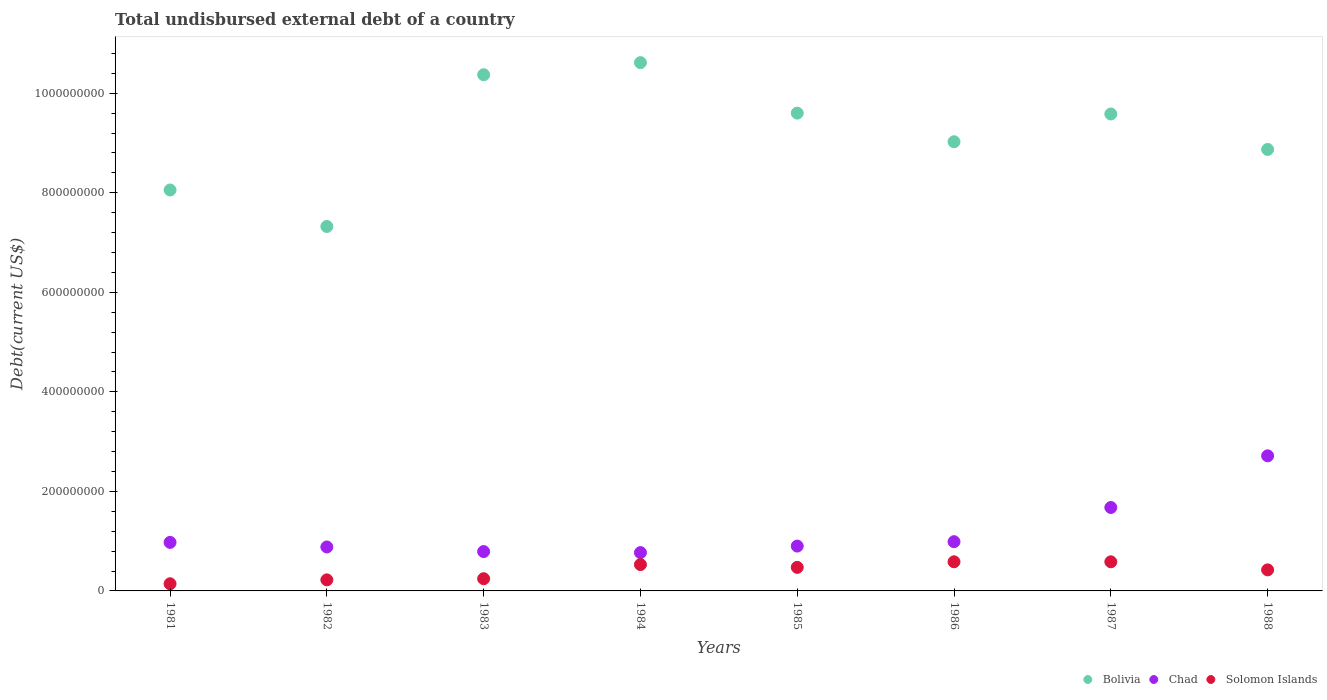What is the total undisbursed external debt in Bolivia in 1988?
Provide a succinct answer. 8.87e+08. Across all years, what is the maximum total undisbursed external debt in Chad?
Offer a terse response. 2.71e+08. Across all years, what is the minimum total undisbursed external debt in Chad?
Keep it short and to the point. 7.70e+07. In which year was the total undisbursed external debt in Bolivia maximum?
Provide a short and direct response. 1984. What is the total total undisbursed external debt in Bolivia in the graph?
Provide a succinct answer. 7.34e+09. What is the difference between the total undisbursed external debt in Chad in 1985 and that in 1987?
Keep it short and to the point. -7.75e+07. What is the difference between the total undisbursed external debt in Chad in 1988 and the total undisbursed external debt in Bolivia in 1982?
Ensure brevity in your answer.  -4.61e+08. What is the average total undisbursed external debt in Solomon Islands per year?
Provide a short and direct response. 4.01e+07. In the year 1984, what is the difference between the total undisbursed external debt in Solomon Islands and total undisbursed external debt in Bolivia?
Offer a terse response. -1.01e+09. What is the ratio of the total undisbursed external debt in Chad in 1983 to that in 1988?
Your answer should be very brief. 0.29. What is the difference between the highest and the second highest total undisbursed external debt in Solomon Islands?
Give a very brief answer. 2.10e+04. What is the difference between the highest and the lowest total undisbursed external debt in Chad?
Your answer should be very brief. 1.94e+08. In how many years, is the total undisbursed external debt in Chad greater than the average total undisbursed external debt in Chad taken over all years?
Your response must be concise. 2. Is the sum of the total undisbursed external debt in Solomon Islands in 1984 and 1988 greater than the maximum total undisbursed external debt in Chad across all years?
Offer a very short reply. No. Is it the case that in every year, the sum of the total undisbursed external debt in Solomon Islands and total undisbursed external debt in Chad  is greater than the total undisbursed external debt in Bolivia?
Make the answer very short. No. Does the total undisbursed external debt in Solomon Islands monotonically increase over the years?
Your answer should be very brief. No. Is the total undisbursed external debt in Bolivia strictly greater than the total undisbursed external debt in Chad over the years?
Keep it short and to the point. Yes. How many years are there in the graph?
Your answer should be very brief. 8. Does the graph contain any zero values?
Make the answer very short. No. Does the graph contain grids?
Make the answer very short. No. How are the legend labels stacked?
Your answer should be very brief. Horizontal. What is the title of the graph?
Your response must be concise. Total undisbursed external debt of a country. What is the label or title of the X-axis?
Your answer should be compact. Years. What is the label or title of the Y-axis?
Provide a succinct answer. Debt(current US$). What is the Debt(current US$) of Bolivia in 1981?
Your answer should be compact. 8.06e+08. What is the Debt(current US$) in Chad in 1981?
Offer a very short reply. 9.75e+07. What is the Debt(current US$) in Solomon Islands in 1981?
Provide a succinct answer. 1.44e+07. What is the Debt(current US$) in Bolivia in 1982?
Provide a succinct answer. 7.32e+08. What is the Debt(current US$) in Chad in 1982?
Your response must be concise. 8.83e+07. What is the Debt(current US$) of Solomon Islands in 1982?
Offer a terse response. 2.22e+07. What is the Debt(current US$) in Bolivia in 1983?
Give a very brief answer. 1.04e+09. What is the Debt(current US$) in Chad in 1983?
Offer a very short reply. 7.91e+07. What is the Debt(current US$) in Solomon Islands in 1983?
Offer a very short reply. 2.45e+07. What is the Debt(current US$) of Bolivia in 1984?
Make the answer very short. 1.06e+09. What is the Debt(current US$) in Chad in 1984?
Your answer should be compact. 7.70e+07. What is the Debt(current US$) in Solomon Islands in 1984?
Give a very brief answer. 5.29e+07. What is the Debt(current US$) in Bolivia in 1985?
Give a very brief answer. 9.60e+08. What is the Debt(current US$) of Chad in 1985?
Give a very brief answer. 9.01e+07. What is the Debt(current US$) of Solomon Islands in 1985?
Your answer should be very brief. 4.73e+07. What is the Debt(current US$) in Bolivia in 1986?
Ensure brevity in your answer.  9.02e+08. What is the Debt(current US$) of Chad in 1986?
Keep it short and to the point. 9.89e+07. What is the Debt(current US$) in Solomon Islands in 1986?
Provide a succinct answer. 5.85e+07. What is the Debt(current US$) of Bolivia in 1987?
Keep it short and to the point. 9.58e+08. What is the Debt(current US$) in Chad in 1987?
Provide a succinct answer. 1.68e+08. What is the Debt(current US$) of Solomon Islands in 1987?
Give a very brief answer. 5.85e+07. What is the Debt(current US$) of Bolivia in 1988?
Your response must be concise. 8.87e+08. What is the Debt(current US$) in Chad in 1988?
Your answer should be compact. 2.71e+08. What is the Debt(current US$) of Solomon Islands in 1988?
Offer a terse response. 4.23e+07. Across all years, what is the maximum Debt(current US$) of Bolivia?
Your response must be concise. 1.06e+09. Across all years, what is the maximum Debt(current US$) in Chad?
Offer a terse response. 2.71e+08. Across all years, what is the maximum Debt(current US$) of Solomon Islands?
Ensure brevity in your answer.  5.85e+07. Across all years, what is the minimum Debt(current US$) of Bolivia?
Offer a terse response. 7.32e+08. Across all years, what is the minimum Debt(current US$) of Chad?
Your answer should be compact. 7.70e+07. Across all years, what is the minimum Debt(current US$) in Solomon Islands?
Give a very brief answer. 1.44e+07. What is the total Debt(current US$) of Bolivia in the graph?
Offer a terse response. 7.34e+09. What is the total Debt(current US$) of Chad in the graph?
Give a very brief answer. 9.70e+08. What is the total Debt(current US$) of Solomon Islands in the graph?
Give a very brief answer. 3.21e+08. What is the difference between the Debt(current US$) of Bolivia in 1981 and that in 1982?
Your answer should be very brief. 7.33e+07. What is the difference between the Debt(current US$) of Chad in 1981 and that in 1982?
Provide a succinct answer. 9.19e+06. What is the difference between the Debt(current US$) of Solomon Islands in 1981 and that in 1982?
Your answer should be very brief. -7.85e+06. What is the difference between the Debt(current US$) of Bolivia in 1981 and that in 1983?
Keep it short and to the point. -2.32e+08. What is the difference between the Debt(current US$) in Chad in 1981 and that in 1983?
Your answer should be compact. 1.84e+07. What is the difference between the Debt(current US$) of Solomon Islands in 1981 and that in 1983?
Your response must be concise. -1.02e+07. What is the difference between the Debt(current US$) in Bolivia in 1981 and that in 1984?
Your answer should be very brief. -2.56e+08. What is the difference between the Debt(current US$) of Chad in 1981 and that in 1984?
Make the answer very short. 2.05e+07. What is the difference between the Debt(current US$) of Solomon Islands in 1981 and that in 1984?
Keep it short and to the point. -3.85e+07. What is the difference between the Debt(current US$) in Bolivia in 1981 and that in 1985?
Your answer should be very brief. -1.54e+08. What is the difference between the Debt(current US$) of Chad in 1981 and that in 1985?
Ensure brevity in your answer.  7.40e+06. What is the difference between the Debt(current US$) in Solomon Islands in 1981 and that in 1985?
Make the answer very short. -3.30e+07. What is the difference between the Debt(current US$) of Bolivia in 1981 and that in 1986?
Your answer should be compact. -9.69e+07. What is the difference between the Debt(current US$) of Chad in 1981 and that in 1986?
Provide a short and direct response. -1.39e+06. What is the difference between the Debt(current US$) in Solomon Islands in 1981 and that in 1986?
Your answer should be compact. -4.42e+07. What is the difference between the Debt(current US$) of Bolivia in 1981 and that in 1987?
Keep it short and to the point. -1.53e+08. What is the difference between the Debt(current US$) in Chad in 1981 and that in 1987?
Your response must be concise. -7.01e+07. What is the difference between the Debt(current US$) of Solomon Islands in 1981 and that in 1987?
Offer a terse response. -4.41e+07. What is the difference between the Debt(current US$) of Bolivia in 1981 and that in 1988?
Keep it short and to the point. -8.15e+07. What is the difference between the Debt(current US$) in Chad in 1981 and that in 1988?
Ensure brevity in your answer.  -1.74e+08. What is the difference between the Debt(current US$) of Solomon Islands in 1981 and that in 1988?
Make the answer very short. -2.79e+07. What is the difference between the Debt(current US$) of Bolivia in 1982 and that in 1983?
Your response must be concise. -3.05e+08. What is the difference between the Debt(current US$) in Chad in 1982 and that in 1983?
Provide a short and direct response. 9.26e+06. What is the difference between the Debt(current US$) in Solomon Islands in 1982 and that in 1983?
Your answer should be compact. -2.31e+06. What is the difference between the Debt(current US$) in Bolivia in 1982 and that in 1984?
Your answer should be very brief. -3.29e+08. What is the difference between the Debt(current US$) of Chad in 1982 and that in 1984?
Offer a terse response. 1.13e+07. What is the difference between the Debt(current US$) of Solomon Islands in 1982 and that in 1984?
Your answer should be compact. -3.07e+07. What is the difference between the Debt(current US$) of Bolivia in 1982 and that in 1985?
Provide a succinct answer. -2.28e+08. What is the difference between the Debt(current US$) of Chad in 1982 and that in 1985?
Provide a short and direct response. -1.78e+06. What is the difference between the Debt(current US$) of Solomon Islands in 1982 and that in 1985?
Your answer should be compact. -2.51e+07. What is the difference between the Debt(current US$) of Bolivia in 1982 and that in 1986?
Offer a very short reply. -1.70e+08. What is the difference between the Debt(current US$) of Chad in 1982 and that in 1986?
Provide a short and direct response. -1.06e+07. What is the difference between the Debt(current US$) of Solomon Islands in 1982 and that in 1986?
Provide a short and direct response. -3.63e+07. What is the difference between the Debt(current US$) of Bolivia in 1982 and that in 1987?
Offer a very short reply. -2.26e+08. What is the difference between the Debt(current US$) of Chad in 1982 and that in 1987?
Provide a succinct answer. -7.93e+07. What is the difference between the Debt(current US$) in Solomon Islands in 1982 and that in 1987?
Provide a succinct answer. -3.63e+07. What is the difference between the Debt(current US$) in Bolivia in 1982 and that in 1988?
Your response must be concise. -1.55e+08. What is the difference between the Debt(current US$) of Chad in 1982 and that in 1988?
Your response must be concise. -1.83e+08. What is the difference between the Debt(current US$) of Solomon Islands in 1982 and that in 1988?
Keep it short and to the point. -2.01e+07. What is the difference between the Debt(current US$) in Bolivia in 1983 and that in 1984?
Offer a terse response. -2.43e+07. What is the difference between the Debt(current US$) in Chad in 1983 and that in 1984?
Give a very brief answer. 2.07e+06. What is the difference between the Debt(current US$) in Solomon Islands in 1983 and that in 1984?
Your answer should be very brief. -2.84e+07. What is the difference between the Debt(current US$) in Bolivia in 1983 and that in 1985?
Offer a terse response. 7.71e+07. What is the difference between the Debt(current US$) of Chad in 1983 and that in 1985?
Offer a terse response. -1.10e+07. What is the difference between the Debt(current US$) of Solomon Islands in 1983 and that in 1985?
Your answer should be very brief. -2.28e+07. What is the difference between the Debt(current US$) in Bolivia in 1983 and that in 1986?
Offer a very short reply. 1.35e+08. What is the difference between the Debt(current US$) of Chad in 1983 and that in 1986?
Make the answer very short. -1.98e+07. What is the difference between the Debt(current US$) of Solomon Islands in 1983 and that in 1986?
Offer a very short reply. -3.40e+07. What is the difference between the Debt(current US$) in Bolivia in 1983 and that in 1987?
Provide a succinct answer. 7.89e+07. What is the difference between the Debt(current US$) of Chad in 1983 and that in 1987?
Offer a very short reply. -8.86e+07. What is the difference between the Debt(current US$) of Solomon Islands in 1983 and that in 1987?
Give a very brief answer. -3.40e+07. What is the difference between the Debt(current US$) of Bolivia in 1983 and that in 1988?
Your answer should be very brief. 1.50e+08. What is the difference between the Debt(current US$) in Chad in 1983 and that in 1988?
Provide a short and direct response. -1.92e+08. What is the difference between the Debt(current US$) of Solomon Islands in 1983 and that in 1988?
Provide a succinct answer. -1.78e+07. What is the difference between the Debt(current US$) of Bolivia in 1984 and that in 1985?
Ensure brevity in your answer.  1.01e+08. What is the difference between the Debt(current US$) of Chad in 1984 and that in 1985?
Make the answer very short. -1.31e+07. What is the difference between the Debt(current US$) of Solomon Islands in 1984 and that in 1985?
Your response must be concise. 5.59e+06. What is the difference between the Debt(current US$) of Bolivia in 1984 and that in 1986?
Provide a succinct answer. 1.59e+08. What is the difference between the Debt(current US$) of Chad in 1984 and that in 1986?
Your answer should be very brief. -2.19e+07. What is the difference between the Debt(current US$) in Solomon Islands in 1984 and that in 1986?
Ensure brevity in your answer.  -5.62e+06. What is the difference between the Debt(current US$) in Bolivia in 1984 and that in 1987?
Keep it short and to the point. 1.03e+08. What is the difference between the Debt(current US$) of Chad in 1984 and that in 1987?
Offer a terse response. -9.06e+07. What is the difference between the Debt(current US$) in Solomon Islands in 1984 and that in 1987?
Offer a terse response. -5.60e+06. What is the difference between the Debt(current US$) in Bolivia in 1984 and that in 1988?
Offer a very short reply. 1.74e+08. What is the difference between the Debt(current US$) in Chad in 1984 and that in 1988?
Give a very brief answer. -1.94e+08. What is the difference between the Debt(current US$) in Solomon Islands in 1984 and that in 1988?
Offer a very short reply. 1.06e+07. What is the difference between the Debt(current US$) in Bolivia in 1985 and that in 1986?
Your response must be concise. 5.75e+07. What is the difference between the Debt(current US$) in Chad in 1985 and that in 1986?
Provide a succinct answer. -8.80e+06. What is the difference between the Debt(current US$) of Solomon Islands in 1985 and that in 1986?
Your response must be concise. -1.12e+07. What is the difference between the Debt(current US$) in Bolivia in 1985 and that in 1987?
Your answer should be compact. 1.75e+06. What is the difference between the Debt(current US$) of Chad in 1985 and that in 1987?
Your answer should be very brief. -7.75e+07. What is the difference between the Debt(current US$) in Solomon Islands in 1985 and that in 1987?
Offer a terse response. -1.12e+07. What is the difference between the Debt(current US$) in Bolivia in 1985 and that in 1988?
Provide a succinct answer. 7.30e+07. What is the difference between the Debt(current US$) of Chad in 1985 and that in 1988?
Give a very brief answer. -1.81e+08. What is the difference between the Debt(current US$) of Solomon Islands in 1985 and that in 1988?
Offer a terse response. 5.04e+06. What is the difference between the Debt(current US$) in Bolivia in 1986 and that in 1987?
Offer a terse response. -5.58e+07. What is the difference between the Debt(current US$) of Chad in 1986 and that in 1987?
Your answer should be compact. -6.87e+07. What is the difference between the Debt(current US$) in Solomon Islands in 1986 and that in 1987?
Make the answer very short. 2.10e+04. What is the difference between the Debt(current US$) of Bolivia in 1986 and that in 1988?
Ensure brevity in your answer.  1.54e+07. What is the difference between the Debt(current US$) in Chad in 1986 and that in 1988?
Your answer should be compact. -1.73e+08. What is the difference between the Debt(current US$) in Solomon Islands in 1986 and that in 1988?
Provide a short and direct response. 1.62e+07. What is the difference between the Debt(current US$) in Bolivia in 1987 and that in 1988?
Provide a succinct answer. 7.12e+07. What is the difference between the Debt(current US$) of Chad in 1987 and that in 1988?
Provide a short and direct response. -1.04e+08. What is the difference between the Debt(current US$) of Solomon Islands in 1987 and that in 1988?
Provide a succinct answer. 1.62e+07. What is the difference between the Debt(current US$) in Bolivia in 1981 and the Debt(current US$) in Chad in 1982?
Give a very brief answer. 7.17e+08. What is the difference between the Debt(current US$) of Bolivia in 1981 and the Debt(current US$) of Solomon Islands in 1982?
Offer a terse response. 7.83e+08. What is the difference between the Debt(current US$) of Chad in 1981 and the Debt(current US$) of Solomon Islands in 1982?
Ensure brevity in your answer.  7.53e+07. What is the difference between the Debt(current US$) in Bolivia in 1981 and the Debt(current US$) in Chad in 1983?
Make the answer very short. 7.26e+08. What is the difference between the Debt(current US$) in Bolivia in 1981 and the Debt(current US$) in Solomon Islands in 1983?
Provide a short and direct response. 7.81e+08. What is the difference between the Debt(current US$) of Chad in 1981 and the Debt(current US$) of Solomon Islands in 1983?
Make the answer very short. 7.30e+07. What is the difference between the Debt(current US$) in Bolivia in 1981 and the Debt(current US$) in Chad in 1984?
Ensure brevity in your answer.  7.29e+08. What is the difference between the Debt(current US$) in Bolivia in 1981 and the Debt(current US$) in Solomon Islands in 1984?
Ensure brevity in your answer.  7.53e+08. What is the difference between the Debt(current US$) of Chad in 1981 and the Debt(current US$) of Solomon Islands in 1984?
Provide a succinct answer. 4.46e+07. What is the difference between the Debt(current US$) in Bolivia in 1981 and the Debt(current US$) in Chad in 1985?
Ensure brevity in your answer.  7.15e+08. What is the difference between the Debt(current US$) in Bolivia in 1981 and the Debt(current US$) in Solomon Islands in 1985?
Offer a very short reply. 7.58e+08. What is the difference between the Debt(current US$) in Chad in 1981 and the Debt(current US$) in Solomon Islands in 1985?
Provide a succinct answer. 5.02e+07. What is the difference between the Debt(current US$) of Bolivia in 1981 and the Debt(current US$) of Chad in 1986?
Your response must be concise. 7.07e+08. What is the difference between the Debt(current US$) in Bolivia in 1981 and the Debt(current US$) in Solomon Islands in 1986?
Your answer should be very brief. 7.47e+08. What is the difference between the Debt(current US$) in Chad in 1981 and the Debt(current US$) in Solomon Islands in 1986?
Your response must be concise. 3.90e+07. What is the difference between the Debt(current US$) of Bolivia in 1981 and the Debt(current US$) of Chad in 1987?
Make the answer very short. 6.38e+08. What is the difference between the Debt(current US$) of Bolivia in 1981 and the Debt(current US$) of Solomon Islands in 1987?
Ensure brevity in your answer.  7.47e+08. What is the difference between the Debt(current US$) in Chad in 1981 and the Debt(current US$) in Solomon Islands in 1987?
Offer a very short reply. 3.90e+07. What is the difference between the Debt(current US$) of Bolivia in 1981 and the Debt(current US$) of Chad in 1988?
Ensure brevity in your answer.  5.34e+08. What is the difference between the Debt(current US$) of Bolivia in 1981 and the Debt(current US$) of Solomon Islands in 1988?
Keep it short and to the point. 7.63e+08. What is the difference between the Debt(current US$) in Chad in 1981 and the Debt(current US$) in Solomon Islands in 1988?
Provide a succinct answer. 5.52e+07. What is the difference between the Debt(current US$) in Bolivia in 1982 and the Debt(current US$) in Chad in 1983?
Your answer should be very brief. 6.53e+08. What is the difference between the Debt(current US$) in Bolivia in 1982 and the Debt(current US$) in Solomon Islands in 1983?
Your answer should be very brief. 7.08e+08. What is the difference between the Debt(current US$) of Chad in 1982 and the Debt(current US$) of Solomon Islands in 1983?
Your answer should be compact. 6.38e+07. What is the difference between the Debt(current US$) of Bolivia in 1982 and the Debt(current US$) of Chad in 1984?
Make the answer very short. 6.55e+08. What is the difference between the Debt(current US$) in Bolivia in 1982 and the Debt(current US$) in Solomon Islands in 1984?
Provide a short and direct response. 6.79e+08. What is the difference between the Debt(current US$) in Chad in 1982 and the Debt(current US$) in Solomon Islands in 1984?
Your answer should be compact. 3.54e+07. What is the difference between the Debt(current US$) in Bolivia in 1982 and the Debt(current US$) in Chad in 1985?
Offer a terse response. 6.42e+08. What is the difference between the Debt(current US$) of Bolivia in 1982 and the Debt(current US$) of Solomon Islands in 1985?
Give a very brief answer. 6.85e+08. What is the difference between the Debt(current US$) in Chad in 1982 and the Debt(current US$) in Solomon Islands in 1985?
Ensure brevity in your answer.  4.10e+07. What is the difference between the Debt(current US$) of Bolivia in 1982 and the Debt(current US$) of Chad in 1986?
Keep it short and to the point. 6.33e+08. What is the difference between the Debt(current US$) in Bolivia in 1982 and the Debt(current US$) in Solomon Islands in 1986?
Give a very brief answer. 6.74e+08. What is the difference between the Debt(current US$) in Chad in 1982 and the Debt(current US$) in Solomon Islands in 1986?
Give a very brief answer. 2.98e+07. What is the difference between the Debt(current US$) in Bolivia in 1982 and the Debt(current US$) in Chad in 1987?
Ensure brevity in your answer.  5.65e+08. What is the difference between the Debt(current US$) in Bolivia in 1982 and the Debt(current US$) in Solomon Islands in 1987?
Your answer should be compact. 6.74e+08. What is the difference between the Debt(current US$) of Chad in 1982 and the Debt(current US$) of Solomon Islands in 1987?
Your answer should be compact. 2.98e+07. What is the difference between the Debt(current US$) in Bolivia in 1982 and the Debt(current US$) in Chad in 1988?
Provide a succinct answer. 4.61e+08. What is the difference between the Debt(current US$) of Bolivia in 1982 and the Debt(current US$) of Solomon Islands in 1988?
Your answer should be compact. 6.90e+08. What is the difference between the Debt(current US$) of Chad in 1982 and the Debt(current US$) of Solomon Islands in 1988?
Make the answer very short. 4.60e+07. What is the difference between the Debt(current US$) of Bolivia in 1983 and the Debt(current US$) of Chad in 1984?
Your response must be concise. 9.60e+08. What is the difference between the Debt(current US$) in Bolivia in 1983 and the Debt(current US$) in Solomon Islands in 1984?
Offer a terse response. 9.84e+08. What is the difference between the Debt(current US$) of Chad in 1983 and the Debt(current US$) of Solomon Islands in 1984?
Provide a succinct answer. 2.61e+07. What is the difference between the Debt(current US$) of Bolivia in 1983 and the Debt(current US$) of Chad in 1985?
Keep it short and to the point. 9.47e+08. What is the difference between the Debt(current US$) in Bolivia in 1983 and the Debt(current US$) in Solomon Islands in 1985?
Ensure brevity in your answer.  9.90e+08. What is the difference between the Debt(current US$) of Chad in 1983 and the Debt(current US$) of Solomon Islands in 1985?
Your answer should be very brief. 3.17e+07. What is the difference between the Debt(current US$) of Bolivia in 1983 and the Debt(current US$) of Chad in 1986?
Provide a succinct answer. 9.38e+08. What is the difference between the Debt(current US$) in Bolivia in 1983 and the Debt(current US$) in Solomon Islands in 1986?
Make the answer very short. 9.79e+08. What is the difference between the Debt(current US$) in Chad in 1983 and the Debt(current US$) in Solomon Islands in 1986?
Give a very brief answer. 2.05e+07. What is the difference between the Debt(current US$) in Bolivia in 1983 and the Debt(current US$) in Chad in 1987?
Your answer should be compact. 8.69e+08. What is the difference between the Debt(current US$) in Bolivia in 1983 and the Debt(current US$) in Solomon Islands in 1987?
Provide a short and direct response. 9.79e+08. What is the difference between the Debt(current US$) in Chad in 1983 and the Debt(current US$) in Solomon Islands in 1987?
Offer a very short reply. 2.05e+07. What is the difference between the Debt(current US$) of Bolivia in 1983 and the Debt(current US$) of Chad in 1988?
Make the answer very short. 7.66e+08. What is the difference between the Debt(current US$) in Bolivia in 1983 and the Debt(current US$) in Solomon Islands in 1988?
Give a very brief answer. 9.95e+08. What is the difference between the Debt(current US$) of Chad in 1983 and the Debt(current US$) of Solomon Islands in 1988?
Make the answer very short. 3.68e+07. What is the difference between the Debt(current US$) in Bolivia in 1984 and the Debt(current US$) in Chad in 1985?
Give a very brief answer. 9.71e+08. What is the difference between the Debt(current US$) in Bolivia in 1984 and the Debt(current US$) in Solomon Islands in 1985?
Make the answer very short. 1.01e+09. What is the difference between the Debt(current US$) of Chad in 1984 and the Debt(current US$) of Solomon Islands in 1985?
Ensure brevity in your answer.  2.97e+07. What is the difference between the Debt(current US$) of Bolivia in 1984 and the Debt(current US$) of Chad in 1986?
Offer a terse response. 9.63e+08. What is the difference between the Debt(current US$) of Bolivia in 1984 and the Debt(current US$) of Solomon Islands in 1986?
Your answer should be compact. 1.00e+09. What is the difference between the Debt(current US$) in Chad in 1984 and the Debt(current US$) in Solomon Islands in 1986?
Ensure brevity in your answer.  1.84e+07. What is the difference between the Debt(current US$) of Bolivia in 1984 and the Debt(current US$) of Chad in 1987?
Offer a very short reply. 8.94e+08. What is the difference between the Debt(current US$) in Bolivia in 1984 and the Debt(current US$) in Solomon Islands in 1987?
Your answer should be compact. 1.00e+09. What is the difference between the Debt(current US$) in Chad in 1984 and the Debt(current US$) in Solomon Islands in 1987?
Provide a short and direct response. 1.85e+07. What is the difference between the Debt(current US$) of Bolivia in 1984 and the Debt(current US$) of Chad in 1988?
Make the answer very short. 7.90e+08. What is the difference between the Debt(current US$) of Bolivia in 1984 and the Debt(current US$) of Solomon Islands in 1988?
Give a very brief answer. 1.02e+09. What is the difference between the Debt(current US$) of Chad in 1984 and the Debt(current US$) of Solomon Islands in 1988?
Provide a short and direct response. 3.47e+07. What is the difference between the Debt(current US$) in Bolivia in 1985 and the Debt(current US$) in Chad in 1986?
Your answer should be very brief. 8.61e+08. What is the difference between the Debt(current US$) in Bolivia in 1985 and the Debt(current US$) in Solomon Islands in 1986?
Provide a succinct answer. 9.01e+08. What is the difference between the Debt(current US$) of Chad in 1985 and the Debt(current US$) of Solomon Islands in 1986?
Provide a short and direct response. 3.16e+07. What is the difference between the Debt(current US$) of Bolivia in 1985 and the Debt(current US$) of Chad in 1987?
Keep it short and to the point. 7.92e+08. What is the difference between the Debt(current US$) in Bolivia in 1985 and the Debt(current US$) in Solomon Islands in 1987?
Offer a very short reply. 9.01e+08. What is the difference between the Debt(current US$) in Chad in 1985 and the Debt(current US$) in Solomon Islands in 1987?
Your answer should be compact. 3.16e+07. What is the difference between the Debt(current US$) in Bolivia in 1985 and the Debt(current US$) in Chad in 1988?
Give a very brief answer. 6.89e+08. What is the difference between the Debt(current US$) in Bolivia in 1985 and the Debt(current US$) in Solomon Islands in 1988?
Give a very brief answer. 9.18e+08. What is the difference between the Debt(current US$) in Chad in 1985 and the Debt(current US$) in Solomon Islands in 1988?
Provide a short and direct response. 4.78e+07. What is the difference between the Debt(current US$) of Bolivia in 1986 and the Debt(current US$) of Chad in 1987?
Your answer should be compact. 7.35e+08. What is the difference between the Debt(current US$) in Bolivia in 1986 and the Debt(current US$) in Solomon Islands in 1987?
Make the answer very short. 8.44e+08. What is the difference between the Debt(current US$) of Chad in 1986 and the Debt(current US$) of Solomon Islands in 1987?
Your answer should be compact. 4.04e+07. What is the difference between the Debt(current US$) of Bolivia in 1986 and the Debt(current US$) of Chad in 1988?
Provide a succinct answer. 6.31e+08. What is the difference between the Debt(current US$) of Bolivia in 1986 and the Debt(current US$) of Solomon Islands in 1988?
Offer a terse response. 8.60e+08. What is the difference between the Debt(current US$) in Chad in 1986 and the Debt(current US$) in Solomon Islands in 1988?
Your answer should be compact. 5.66e+07. What is the difference between the Debt(current US$) in Bolivia in 1987 and the Debt(current US$) in Chad in 1988?
Your response must be concise. 6.87e+08. What is the difference between the Debt(current US$) in Bolivia in 1987 and the Debt(current US$) in Solomon Islands in 1988?
Make the answer very short. 9.16e+08. What is the difference between the Debt(current US$) in Chad in 1987 and the Debt(current US$) in Solomon Islands in 1988?
Make the answer very short. 1.25e+08. What is the average Debt(current US$) of Bolivia per year?
Your answer should be very brief. 9.18e+08. What is the average Debt(current US$) of Chad per year?
Your response must be concise. 1.21e+08. What is the average Debt(current US$) of Solomon Islands per year?
Keep it short and to the point. 4.01e+07. In the year 1981, what is the difference between the Debt(current US$) of Bolivia and Debt(current US$) of Chad?
Offer a terse response. 7.08e+08. In the year 1981, what is the difference between the Debt(current US$) in Bolivia and Debt(current US$) in Solomon Islands?
Your response must be concise. 7.91e+08. In the year 1981, what is the difference between the Debt(current US$) in Chad and Debt(current US$) in Solomon Islands?
Offer a terse response. 8.31e+07. In the year 1982, what is the difference between the Debt(current US$) of Bolivia and Debt(current US$) of Chad?
Give a very brief answer. 6.44e+08. In the year 1982, what is the difference between the Debt(current US$) in Bolivia and Debt(current US$) in Solomon Islands?
Give a very brief answer. 7.10e+08. In the year 1982, what is the difference between the Debt(current US$) of Chad and Debt(current US$) of Solomon Islands?
Provide a succinct answer. 6.61e+07. In the year 1983, what is the difference between the Debt(current US$) of Bolivia and Debt(current US$) of Chad?
Provide a succinct answer. 9.58e+08. In the year 1983, what is the difference between the Debt(current US$) in Bolivia and Debt(current US$) in Solomon Islands?
Give a very brief answer. 1.01e+09. In the year 1983, what is the difference between the Debt(current US$) of Chad and Debt(current US$) of Solomon Islands?
Keep it short and to the point. 5.45e+07. In the year 1984, what is the difference between the Debt(current US$) in Bolivia and Debt(current US$) in Chad?
Keep it short and to the point. 9.84e+08. In the year 1984, what is the difference between the Debt(current US$) in Bolivia and Debt(current US$) in Solomon Islands?
Your answer should be very brief. 1.01e+09. In the year 1984, what is the difference between the Debt(current US$) in Chad and Debt(current US$) in Solomon Islands?
Offer a terse response. 2.41e+07. In the year 1985, what is the difference between the Debt(current US$) in Bolivia and Debt(current US$) in Chad?
Provide a succinct answer. 8.70e+08. In the year 1985, what is the difference between the Debt(current US$) in Bolivia and Debt(current US$) in Solomon Islands?
Ensure brevity in your answer.  9.13e+08. In the year 1985, what is the difference between the Debt(current US$) in Chad and Debt(current US$) in Solomon Islands?
Your answer should be very brief. 4.28e+07. In the year 1986, what is the difference between the Debt(current US$) of Bolivia and Debt(current US$) of Chad?
Your response must be concise. 8.04e+08. In the year 1986, what is the difference between the Debt(current US$) of Bolivia and Debt(current US$) of Solomon Islands?
Provide a short and direct response. 8.44e+08. In the year 1986, what is the difference between the Debt(current US$) in Chad and Debt(current US$) in Solomon Islands?
Make the answer very short. 4.04e+07. In the year 1987, what is the difference between the Debt(current US$) of Bolivia and Debt(current US$) of Chad?
Provide a succinct answer. 7.91e+08. In the year 1987, what is the difference between the Debt(current US$) of Bolivia and Debt(current US$) of Solomon Islands?
Offer a very short reply. 9.00e+08. In the year 1987, what is the difference between the Debt(current US$) in Chad and Debt(current US$) in Solomon Islands?
Make the answer very short. 1.09e+08. In the year 1988, what is the difference between the Debt(current US$) of Bolivia and Debt(current US$) of Chad?
Keep it short and to the point. 6.16e+08. In the year 1988, what is the difference between the Debt(current US$) in Bolivia and Debt(current US$) in Solomon Islands?
Your answer should be compact. 8.45e+08. In the year 1988, what is the difference between the Debt(current US$) in Chad and Debt(current US$) in Solomon Islands?
Your answer should be very brief. 2.29e+08. What is the ratio of the Debt(current US$) of Bolivia in 1981 to that in 1982?
Ensure brevity in your answer.  1.1. What is the ratio of the Debt(current US$) in Chad in 1981 to that in 1982?
Your answer should be compact. 1.1. What is the ratio of the Debt(current US$) of Solomon Islands in 1981 to that in 1982?
Your response must be concise. 0.65. What is the ratio of the Debt(current US$) in Bolivia in 1981 to that in 1983?
Keep it short and to the point. 0.78. What is the ratio of the Debt(current US$) of Chad in 1981 to that in 1983?
Ensure brevity in your answer.  1.23. What is the ratio of the Debt(current US$) of Solomon Islands in 1981 to that in 1983?
Keep it short and to the point. 0.59. What is the ratio of the Debt(current US$) in Bolivia in 1981 to that in 1984?
Offer a very short reply. 0.76. What is the ratio of the Debt(current US$) in Chad in 1981 to that in 1984?
Your answer should be compact. 1.27. What is the ratio of the Debt(current US$) in Solomon Islands in 1981 to that in 1984?
Keep it short and to the point. 0.27. What is the ratio of the Debt(current US$) in Bolivia in 1981 to that in 1985?
Provide a succinct answer. 0.84. What is the ratio of the Debt(current US$) in Chad in 1981 to that in 1985?
Give a very brief answer. 1.08. What is the ratio of the Debt(current US$) in Solomon Islands in 1981 to that in 1985?
Offer a terse response. 0.3. What is the ratio of the Debt(current US$) in Bolivia in 1981 to that in 1986?
Offer a terse response. 0.89. What is the ratio of the Debt(current US$) of Chad in 1981 to that in 1986?
Provide a succinct answer. 0.99. What is the ratio of the Debt(current US$) in Solomon Islands in 1981 to that in 1986?
Provide a succinct answer. 0.25. What is the ratio of the Debt(current US$) in Bolivia in 1981 to that in 1987?
Offer a terse response. 0.84. What is the ratio of the Debt(current US$) in Chad in 1981 to that in 1987?
Provide a succinct answer. 0.58. What is the ratio of the Debt(current US$) of Solomon Islands in 1981 to that in 1987?
Provide a succinct answer. 0.25. What is the ratio of the Debt(current US$) of Bolivia in 1981 to that in 1988?
Give a very brief answer. 0.91. What is the ratio of the Debt(current US$) of Chad in 1981 to that in 1988?
Your answer should be very brief. 0.36. What is the ratio of the Debt(current US$) in Solomon Islands in 1981 to that in 1988?
Provide a succinct answer. 0.34. What is the ratio of the Debt(current US$) in Bolivia in 1982 to that in 1983?
Keep it short and to the point. 0.71. What is the ratio of the Debt(current US$) in Chad in 1982 to that in 1983?
Your answer should be compact. 1.12. What is the ratio of the Debt(current US$) in Solomon Islands in 1982 to that in 1983?
Ensure brevity in your answer.  0.91. What is the ratio of the Debt(current US$) of Bolivia in 1982 to that in 1984?
Give a very brief answer. 0.69. What is the ratio of the Debt(current US$) of Chad in 1982 to that in 1984?
Give a very brief answer. 1.15. What is the ratio of the Debt(current US$) in Solomon Islands in 1982 to that in 1984?
Your answer should be compact. 0.42. What is the ratio of the Debt(current US$) in Bolivia in 1982 to that in 1985?
Give a very brief answer. 0.76. What is the ratio of the Debt(current US$) of Chad in 1982 to that in 1985?
Your answer should be very brief. 0.98. What is the ratio of the Debt(current US$) in Solomon Islands in 1982 to that in 1985?
Your answer should be very brief. 0.47. What is the ratio of the Debt(current US$) of Bolivia in 1982 to that in 1986?
Offer a very short reply. 0.81. What is the ratio of the Debt(current US$) of Chad in 1982 to that in 1986?
Your response must be concise. 0.89. What is the ratio of the Debt(current US$) of Solomon Islands in 1982 to that in 1986?
Your answer should be very brief. 0.38. What is the ratio of the Debt(current US$) of Bolivia in 1982 to that in 1987?
Your answer should be compact. 0.76. What is the ratio of the Debt(current US$) of Chad in 1982 to that in 1987?
Keep it short and to the point. 0.53. What is the ratio of the Debt(current US$) in Solomon Islands in 1982 to that in 1987?
Make the answer very short. 0.38. What is the ratio of the Debt(current US$) of Bolivia in 1982 to that in 1988?
Offer a very short reply. 0.83. What is the ratio of the Debt(current US$) of Chad in 1982 to that in 1988?
Offer a terse response. 0.33. What is the ratio of the Debt(current US$) in Solomon Islands in 1982 to that in 1988?
Ensure brevity in your answer.  0.53. What is the ratio of the Debt(current US$) in Bolivia in 1983 to that in 1984?
Provide a succinct answer. 0.98. What is the ratio of the Debt(current US$) in Chad in 1983 to that in 1984?
Provide a short and direct response. 1.03. What is the ratio of the Debt(current US$) in Solomon Islands in 1983 to that in 1984?
Keep it short and to the point. 0.46. What is the ratio of the Debt(current US$) in Bolivia in 1983 to that in 1985?
Give a very brief answer. 1.08. What is the ratio of the Debt(current US$) in Chad in 1983 to that in 1985?
Your response must be concise. 0.88. What is the ratio of the Debt(current US$) of Solomon Islands in 1983 to that in 1985?
Offer a very short reply. 0.52. What is the ratio of the Debt(current US$) in Bolivia in 1983 to that in 1986?
Offer a very short reply. 1.15. What is the ratio of the Debt(current US$) in Chad in 1983 to that in 1986?
Make the answer very short. 0.8. What is the ratio of the Debt(current US$) of Solomon Islands in 1983 to that in 1986?
Provide a short and direct response. 0.42. What is the ratio of the Debt(current US$) of Bolivia in 1983 to that in 1987?
Give a very brief answer. 1.08. What is the ratio of the Debt(current US$) in Chad in 1983 to that in 1987?
Provide a succinct answer. 0.47. What is the ratio of the Debt(current US$) in Solomon Islands in 1983 to that in 1987?
Keep it short and to the point. 0.42. What is the ratio of the Debt(current US$) in Bolivia in 1983 to that in 1988?
Offer a terse response. 1.17. What is the ratio of the Debt(current US$) in Chad in 1983 to that in 1988?
Keep it short and to the point. 0.29. What is the ratio of the Debt(current US$) of Solomon Islands in 1983 to that in 1988?
Your response must be concise. 0.58. What is the ratio of the Debt(current US$) of Bolivia in 1984 to that in 1985?
Offer a terse response. 1.11. What is the ratio of the Debt(current US$) of Chad in 1984 to that in 1985?
Provide a succinct answer. 0.85. What is the ratio of the Debt(current US$) of Solomon Islands in 1984 to that in 1985?
Keep it short and to the point. 1.12. What is the ratio of the Debt(current US$) of Bolivia in 1984 to that in 1986?
Your response must be concise. 1.18. What is the ratio of the Debt(current US$) of Chad in 1984 to that in 1986?
Give a very brief answer. 0.78. What is the ratio of the Debt(current US$) in Solomon Islands in 1984 to that in 1986?
Provide a short and direct response. 0.9. What is the ratio of the Debt(current US$) of Bolivia in 1984 to that in 1987?
Offer a very short reply. 1.11. What is the ratio of the Debt(current US$) in Chad in 1984 to that in 1987?
Your answer should be very brief. 0.46. What is the ratio of the Debt(current US$) of Solomon Islands in 1984 to that in 1987?
Give a very brief answer. 0.9. What is the ratio of the Debt(current US$) in Bolivia in 1984 to that in 1988?
Offer a terse response. 1.2. What is the ratio of the Debt(current US$) of Chad in 1984 to that in 1988?
Provide a short and direct response. 0.28. What is the ratio of the Debt(current US$) of Solomon Islands in 1984 to that in 1988?
Give a very brief answer. 1.25. What is the ratio of the Debt(current US$) of Bolivia in 1985 to that in 1986?
Offer a very short reply. 1.06. What is the ratio of the Debt(current US$) in Chad in 1985 to that in 1986?
Provide a short and direct response. 0.91. What is the ratio of the Debt(current US$) in Solomon Islands in 1985 to that in 1986?
Offer a very short reply. 0.81. What is the ratio of the Debt(current US$) in Bolivia in 1985 to that in 1987?
Ensure brevity in your answer.  1. What is the ratio of the Debt(current US$) in Chad in 1985 to that in 1987?
Your response must be concise. 0.54. What is the ratio of the Debt(current US$) of Solomon Islands in 1985 to that in 1987?
Ensure brevity in your answer.  0.81. What is the ratio of the Debt(current US$) of Bolivia in 1985 to that in 1988?
Make the answer very short. 1.08. What is the ratio of the Debt(current US$) in Chad in 1985 to that in 1988?
Offer a terse response. 0.33. What is the ratio of the Debt(current US$) in Solomon Islands in 1985 to that in 1988?
Offer a terse response. 1.12. What is the ratio of the Debt(current US$) in Bolivia in 1986 to that in 1987?
Your answer should be compact. 0.94. What is the ratio of the Debt(current US$) in Chad in 1986 to that in 1987?
Your answer should be compact. 0.59. What is the ratio of the Debt(current US$) in Bolivia in 1986 to that in 1988?
Your response must be concise. 1.02. What is the ratio of the Debt(current US$) of Chad in 1986 to that in 1988?
Offer a very short reply. 0.36. What is the ratio of the Debt(current US$) in Solomon Islands in 1986 to that in 1988?
Offer a terse response. 1.38. What is the ratio of the Debt(current US$) of Bolivia in 1987 to that in 1988?
Provide a succinct answer. 1.08. What is the ratio of the Debt(current US$) in Chad in 1987 to that in 1988?
Provide a succinct answer. 0.62. What is the ratio of the Debt(current US$) in Solomon Islands in 1987 to that in 1988?
Keep it short and to the point. 1.38. What is the difference between the highest and the second highest Debt(current US$) in Bolivia?
Provide a succinct answer. 2.43e+07. What is the difference between the highest and the second highest Debt(current US$) in Chad?
Your answer should be compact. 1.04e+08. What is the difference between the highest and the second highest Debt(current US$) in Solomon Islands?
Make the answer very short. 2.10e+04. What is the difference between the highest and the lowest Debt(current US$) in Bolivia?
Offer a terse response. 3.29e+08. What is the difference between the highest and the lowest Debt(current US$) in Chad?
Make the answer very short. 1.94e+08. What is the difference between the highest and the lowest Debt(current US$) of Solomon Islands?
Offer a terse response. 4.42e+07. 